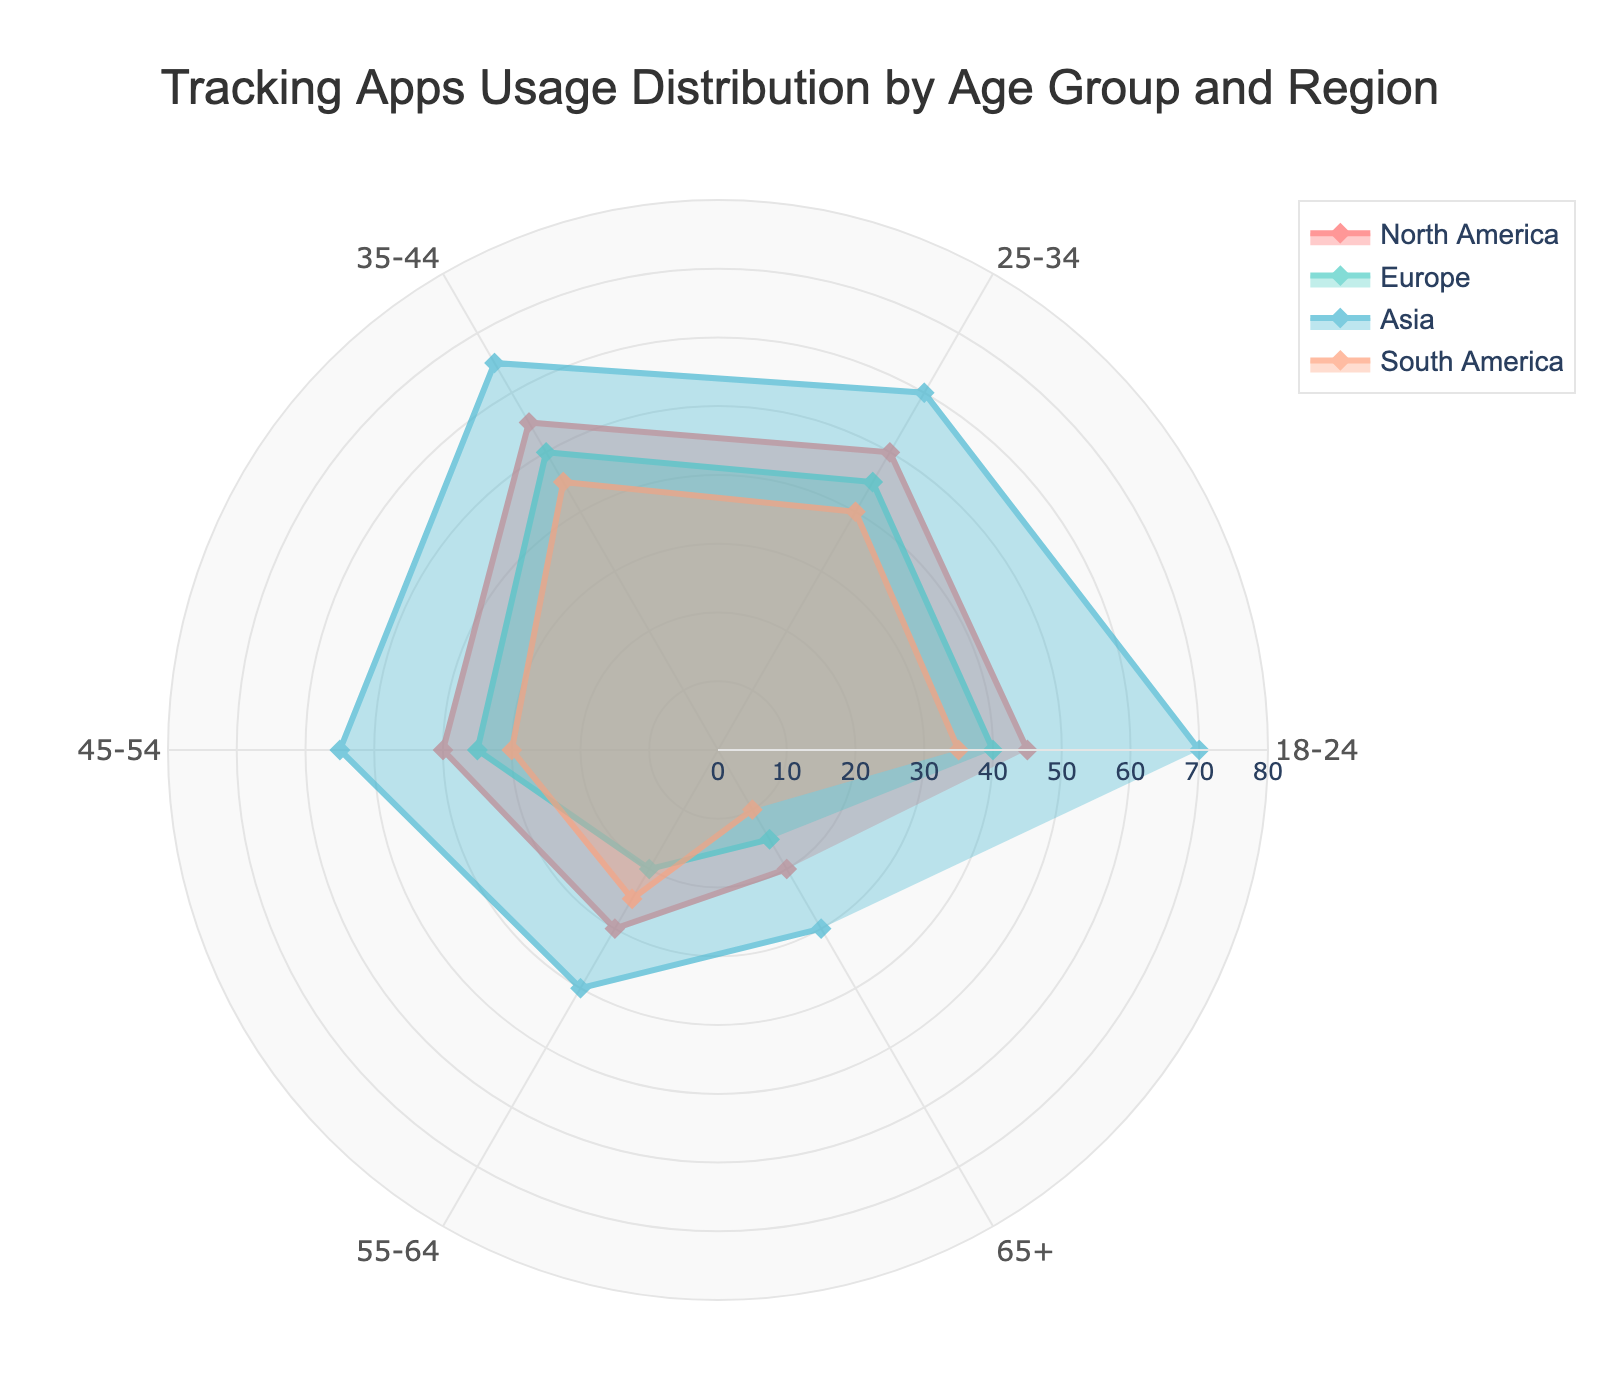what is the title of the chart? The title is placed at the top of the chart and is meant to describe the overall purpose of the visualization. It gives context to the viewers about what information is being conveyed by the chart.
Answer: Tracking Apps Usage Distribution by Age Group and Region Which region has the highest usage in the 25-34 age group? By examining the values for the 25-34 age group across the regions, you can see which region has the largest value.
Answer: North America What is the range of tracking app usage values shown on the chart? The radial axis of the polar chart shows the range of values plotted. It determines the minimum and maximum possible values that can be indicated. The given values range from 0 to 80.
Answer: 0 to 80 How does the tracking app usage in the 55-64 age group compare between North America and Asia? Look at the values for the 55-64 age group for both North America and Asia. North America has a value of 30, whereas Asia has a value of 40.
Answer: Asia has higher usage Which age group has the lowest usage in South America? By examining the values in South America column for all age groups, the age group with the smallest value should be identified.
Answer: 65+ If you combine the usage values for age groups 45-54 and 55-64 in Europe, what's the total usage? Look at the respective values for the 45-54 and 55-64 age groups in Europe and add them together. This combines the usage numbers for those two age groups.
Answer: Total usage is 35+20 = 55 In which region do people aged 18-24 have the lowest tracking app usage? By comparing the values for the 18-24 age group across each region, identify the region with the smallest value. South America has the lowest usage for this age group.
Answer: South America What pattern or trend can be observed in tracking app usage as the age increases in North America? Analyze the values in the North America column from the youngest to the oldest age group. As the age increases, there is a general decrease from 18-24 to 65+.
Answer: Usage decreases with age 